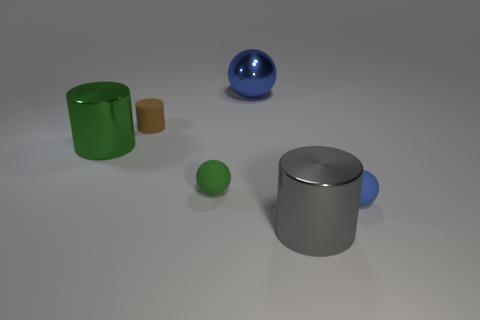Subtract 1 balls. How many balls are left? 2 Add 1 small rubber things. How many objects exist? 7 Add 5 large shiny cylinders. How many large shiny cylinders exist? 7 Subtract 0 cyan balls. How many objects are left? 6 Subtract all small cyan metal cubes. Subtract all large balls. How many objects are left? 5 Add 2 large spheres. How many large spheres are left? 3 